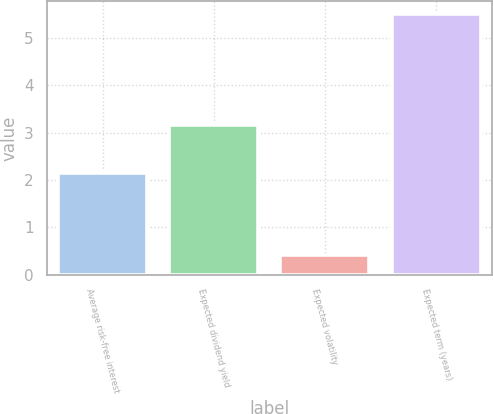<chart> <loc_0><loc_0><loc_500><loc_500><bar_chart><fcel>Average risk-free interest<fcel>Expected dividend yield<fcel>Expected volatility<fcel>Expected term (years)<nl><fcel>2.15<fcel>3.16<fcel>0.41<fcel>5.5<nl></chart> 